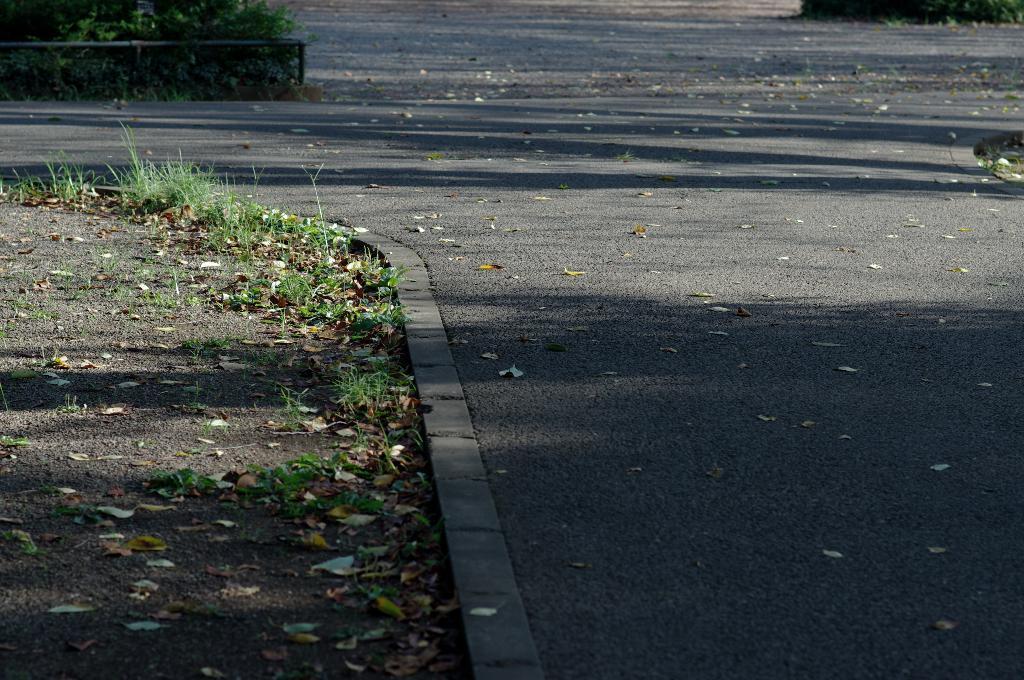Could you give a brief overview of what you see in this image? In this picture we can see a road, here we can see a fence, plants, grass and dried leaves. 